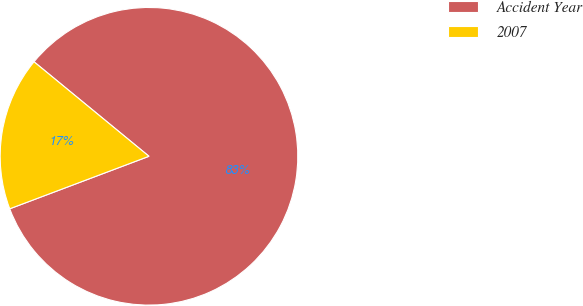Convert chart to OTSL. <chart><loc_0><loc_0><loc_500><loc_500><pie_chart><fcel>Accident Year<fcel>2007<nl><fcel>83.31%<fcel>16.69%<nl></chart> 